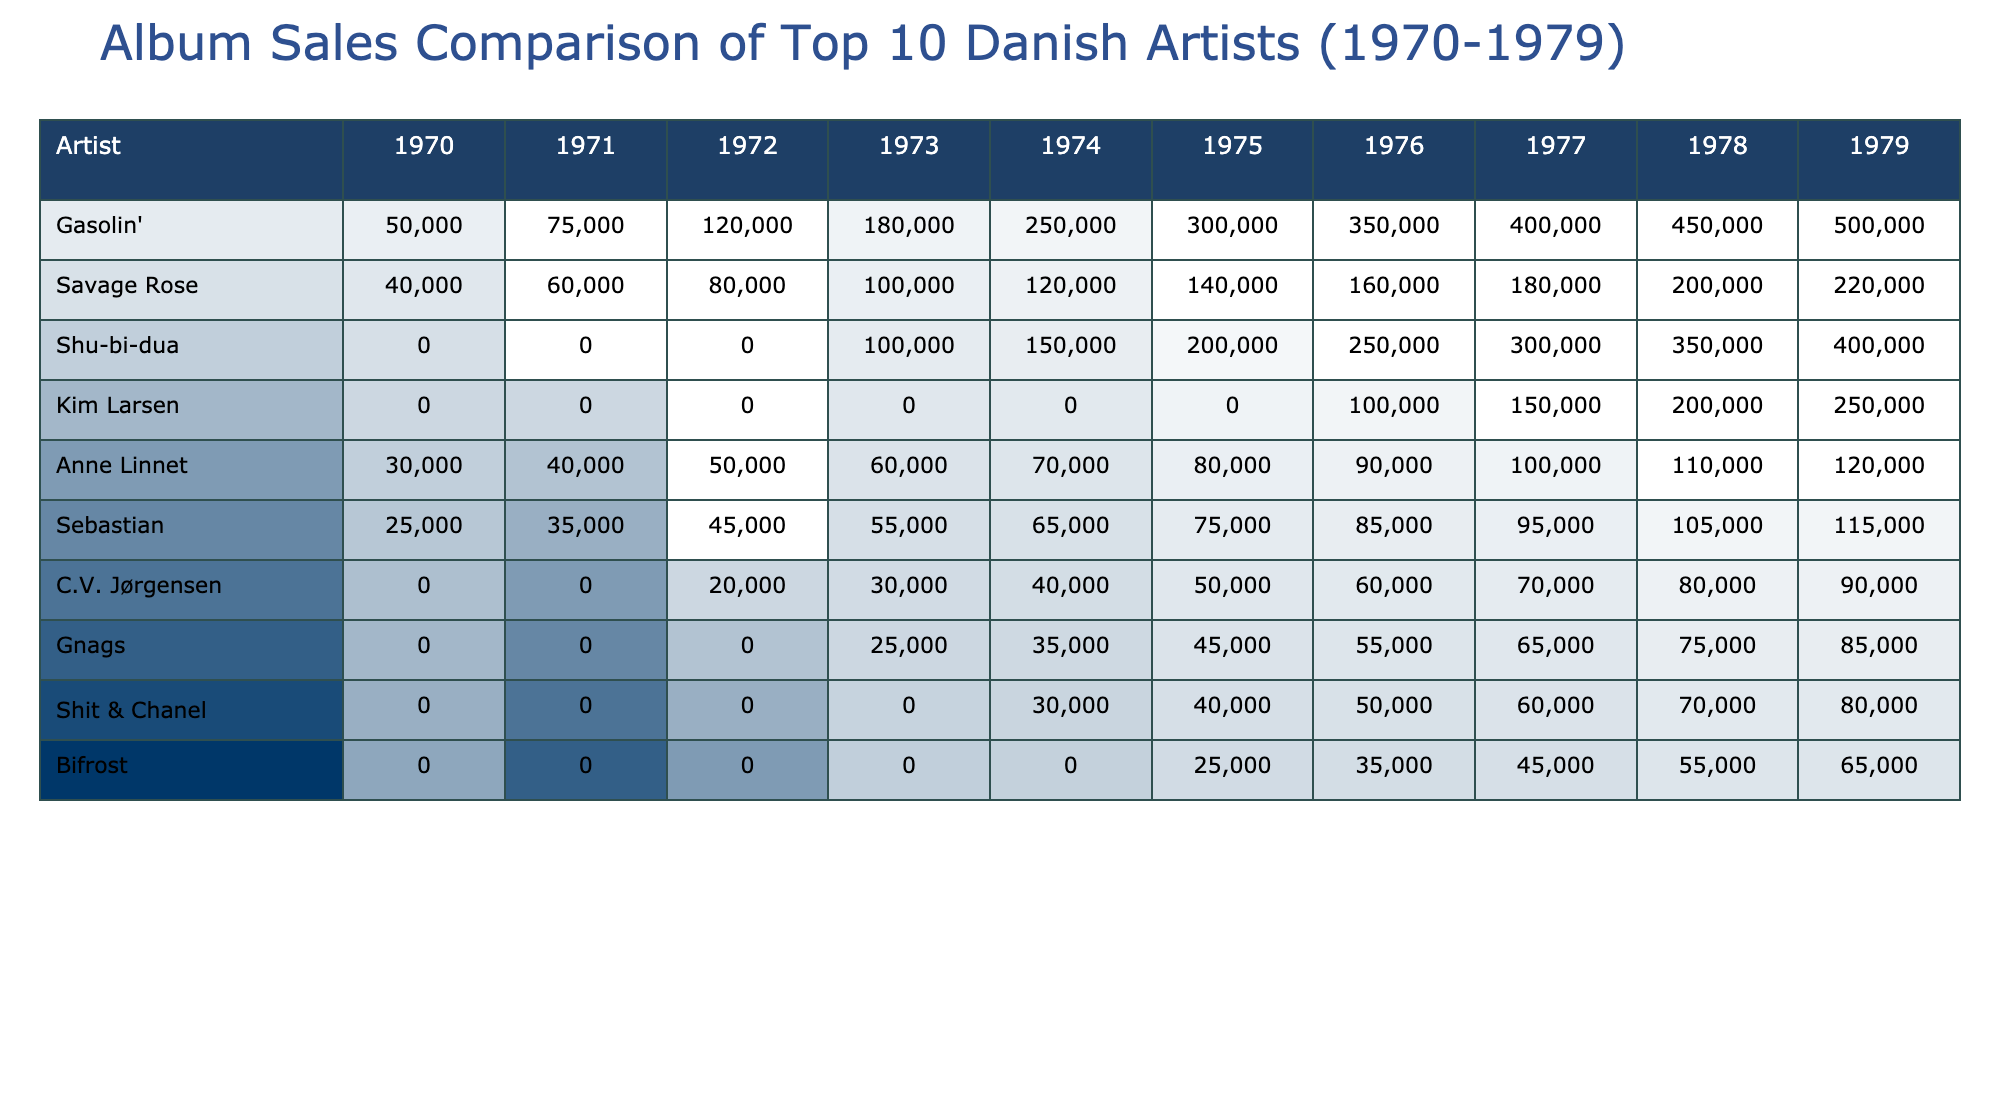What was the total album sales for Gasolin' in 1975? Looking at the row for Gasolin', the sales for 1975 are listed as 300,000.
Answer: 300,000 Which artist had the highest album sales in 1978? In the year 1978, the artist with the highest sales is Gasolin', with sales of 450,000.
Answer: Gasolin' What was the average album sales for Savage Rose from 1970 to 1979? The sales for Savage Rose from 1970 to 1979 are 40,000, 60,000, 80,000, 100,000, 120,000, 140,000, 160,000, 180,000, 200,000, and 220,000. Summing these sales equals 1,100,000. Divided by 10 (the number of years), the average is 110,000.
Answer: 110,000 Did Shu-bi-dua have any sales before 1973? Checking the sales data for Shu-bi-dua, it is evident that there are zero sales for 1970, 1971, and 1972. Therefore, the answer is yes, they had no sales before 1973.
Answer: Yes What is the difference in album sales between Anne Linnet in 1970 and Kim Larsen in 1978? Anne Linnet sold 30,000 in 1970, while Kim Larsen sold 200,000 in 1978. The difference in sales is 200,000 - 30,000 = 170,000.
Answer: 170,000 Which artist consistently increased album sales every year from 1970 to 1979? Examining the sales data, Gasolin' shows a continuous increase in sales every year from 1970 to 1979, starting from 50,000 in 1970 up to 500,000 in 1979.
Answer: Gasolin' What were the total album sales for the bottom three artists in 1977? The bottom three artists by sales in 1977 are Bifrost with 450,000, Shit & Chanel with 600,000, and Gnags with 650,000. Adding these gives 450,000 + 600,000 + 650,000 = 1,700,000.
Answer: 1,700,000 Did C.V. Jørgensen ever exceed 100,000 album sales in any year? Looking at the yearly sales data for C.V. Jørgensen, the maximum sales reached is 90,000 in 1979. Therefore, they never exceeded 100,000.
Answer: No What is the sum of sales for Sebastian from 1970 to 1979? To find the sum for Sebastian, we add the sales figures from each year: 25,000 + 35,000 + 45,000 + 55,000 + 65,000 + 75,000 + 85,000 + 95,000 + 105,000 + 115,000, which equals 600,000.
Answer: 600,000 How many artists had album sales over 200,000 in 1979? In 1979, both Gasolin' (500,000) and Shu-bi-dua (400,000) had album sales over 200,000. Therefore, the total is 2 artists.
Answer: 2 